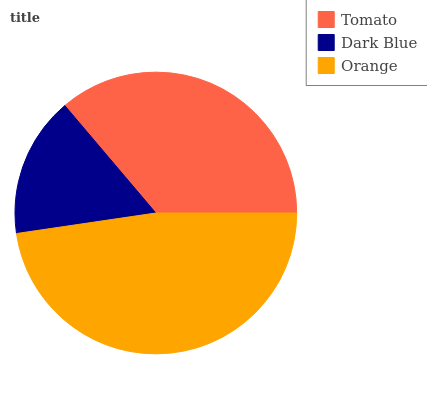Is Dark Blue the minimum?
Answer yes or no. Yes. Is Orange the maximum?
Answer yes or no. Yes. Is Orange the minimum?
Answer yes or no. No. Is Dark Blue the maximum?
Answer yes or no. No. Is Orange greater than Dark Blue?
Answer yes or no. Yes. Is Dark Blue less than Orange?
Answer yes or no. Yes. Is Dark Blue greater than Orange?
Answer yes or no. No. Is Orange less than Dark Blue?
Answer yes or no. No. Is Tomato the high median?
Answer yes or no. Yes. Is Tomato the low median?
Answer yes or no. Yes. Is Dark Blue the high median?
Answer yes or no. No. Is Dark Blue the low median?
Answer yes or no. No. 